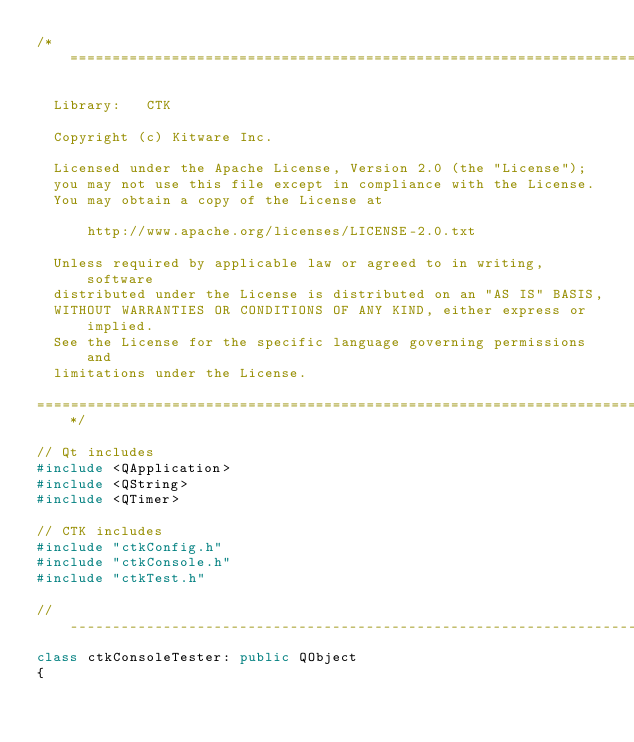Convert code to text. <code><loc_0><loc_0><loc_500><loc_500><_C++_>/*=========================================================================

  Library:   CTK

  Copyright (c) Kitware Inc.

  Licensed under the Apache License, Version 2.0 (the "License");
  you may not use this file except in compliance with the License.
  You may obtain a copy of the License at

      http://www.apache.org/licenses/LICENSE-2.0.txt

  Unless required by applicable law or agreed to in writing, software
  distributed under the License is distributed on an "AS IS" BASIS,
  WITHOUT WARRANTIES OR CONDITIONS OF ANY KIND, either express or implied.
  See the License for the specific language governing permissions and
  limitations under the License.

=========================================================================*/

// Qt includes
#include <QApplication>
#include <QString>
#include <QTimer>

// CTK includes
#include "ctkConfig.h"
#include "ctkConsole.h"
#include "ctkTest.h"

// ----------------------------------------------------------------------------
class ctkConsoleTester: public QObject
{</code> 